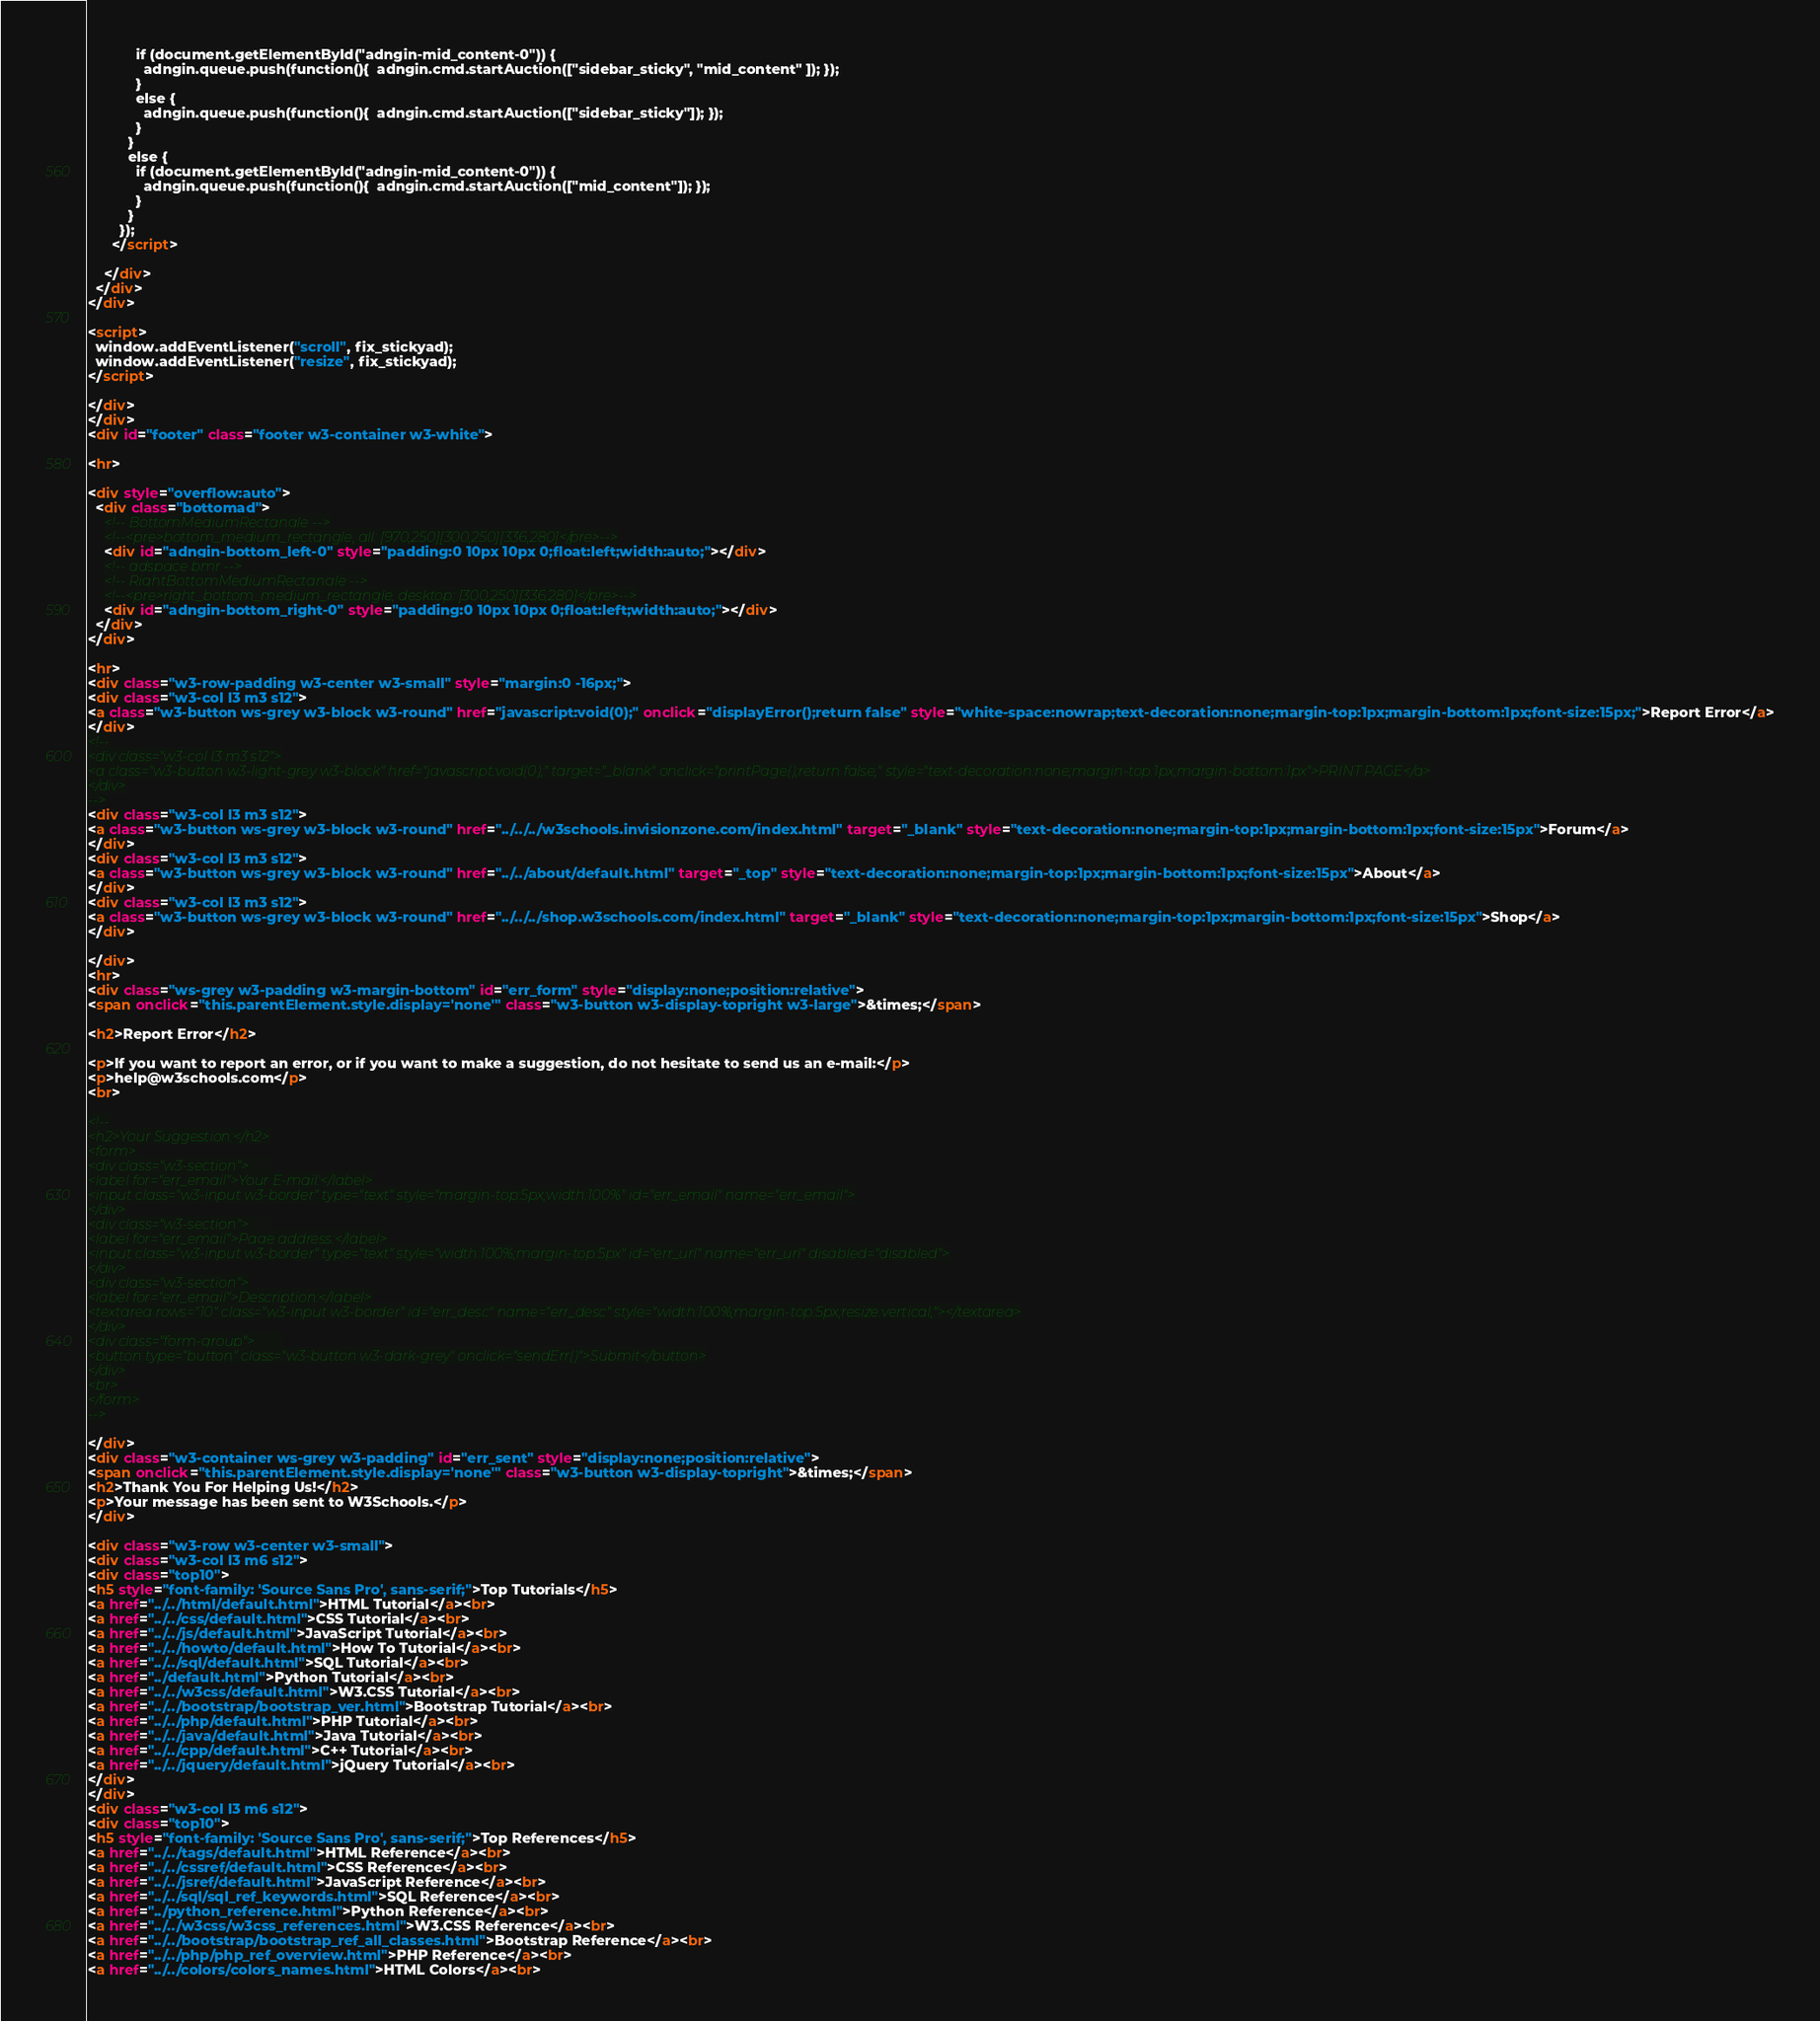<code> <loc_0><loc_0><loc_500><loc_500><_HTML_>            if (document.getElementById("adngin-mid_content-0")) {
              adngin.queue.push(function(){  adngin.cmd.startAuction(["sidebar_sticky", "mid_content" ]); });
            }
            else {
              adngin.queue.push(function(){  adngin.cmd.startAuction(["sidebar_sticky"]); });
            }
          }
          else {
            if (document.getElementById("adngin-mid_content-0")) {
              adngin.queue.push(function(){  adngin.cmd.startAuction(["mid_content"]); });
            }
          }  
        });
      </script>    
      
    </div>
  </div>
</div>

<script>
  window.addEventListener("scroll", fix_stickyad);
  window.addEventListener("resize", fix_stickyad);
</script>

</div>
</div>
<div id="footer" class="footer w3-container w3-white">

<hr>

<div style="overflow:auto">
  <div class="bottomad">
    <!-- BottomMediumRectangle -->
    <!--<pre>bottom_medium_rectangle, all: [970,250][300,250][336,280]</pre>-->
    <div id="adngin-bottom_left-0" style="padding:0 10px 10px 0;float:left;width:auto;"></div>
    <!-- adspace bmr -->
    <!-- RightBottomMediumRectangle -->
    <!--<pre>right_bottom_medium_rectangle, desktop: [300,250][336,280]</pre>-->
    <div id="adngin-bottom_right-0" style="padding:0 10px 10px 0;float:left;width:auto;"></div>
  </div>
</div>

<hr>
<div class="w3-row-padding w3-center w3-small" style="margin:0 -16px;">
<div class="w3-col l3 m3 s12">
<a class="w3-button ws-grey w3-block w3-round" href="javascript:void(0);" onclick="displayError();return false" style="white-space:nowrap;text-decoration:none;margin-top:1px;margin-bottom:1px;font-size:15px;">Report Error</a>
</div>
<!--
<div class="w3-col l3 m3 s12">
<a class="w3-button w3-light-grey w3-block" href="javascript:void(0);" target="_blank" onclick="printPage();return false;" style="text-decoration:none;margin-top:1px;margin-bottom:1px">PRINT PAGE</a>
</div>
-->
<div class="w3-col l3 m3 s12">
<a class="w3-button ws-grey w3-block w3-round" href="../../../w3schools.invisionzone.com/index.html" target="_blank" style="text-decoration:none;margin-top:1px;margin-bottom:1px;font-size:15px">Forum</a>
</div>
<div class="w3-col l3 m3 s12">
<a class="w3-button ws-grey w3-block w3-round" href="../../about/default.html" target="_top" style="text-decoration:none;margin-top:1px;margin-bottom:1px;font-size:15px">About</a>
</div>
<div class="w3-col l3 m3 s12">
<a class="w3-button ws-grey w3-block w3-round" href="../../../shop.w3schools.com/index.html" target="_blank" style="text-decoration:none;margin-top:1px;margin-bottom:1px;font-size:15px">Shop</a>
</div>

</div>
<hr>
<div class="ws-grey w3-padding w3-margin-bottom" id="err_form" style="display:none;position:relative">
<span onclick="this.parentElement.style.display='none'" class="w3-button w3-display-topright w3-large">&times;</span>

<h2>Report Error</h2>

<p>If you want to report an error, or if you want to make a suggestion, do not hesitate to send us an e-mail:</p>
<p>help@w3schools.com</p>
<br>

<!--
<h2>Your Suggestion:</h2>
<form>
<div class="w3-section">      
<label for="err_email">Your E-mail:</label>
<input class="w3-input w3-border" type="text" style="margin-top:5px;width:100%" id="err_email" name="err_email">
</div>
<div class="w3-section">      
<label for="err_email">Page address:</label>
<input class="w3-input w3-border" type="text" style="width:100%;margin-top:5px" id="err_url" name="err_url" disabled="disabled">
</div>
<div class="w3-section">
<label for="err_email">Description:</label>
<textarea rows="10" class="w3-input w3-border" id="err_desc" name="err_desc" style="width:100%;margin-top:5px;resize:vertical;"></textarea>
</div>
<div class="form-group">        
<button type="button" class="w3-button w3-dark-grey" onclick="sendErr()">Submit</button>
</div>
<br>
</form>
-->

</div>
<div class="w3-container ws-grey w3-padding" id="err_sent" style="display:none;position:relative">
<span onclick="this.parentElement.style.display='none'" class="w3-button w3-display-topright">&times;</span>     
<h2>Thank You For Helping Us!</h2>
<p>Your message has been sent to W3Schools.</p>
</div>

<div class="w3-row w3-center w3-small">
<div class="w3-col l3 m6 s12">
<div class="top10">
<h5 style="font-family: 'Source Sans Pro', sans-serif;">Top Tutorials</h5>
<a href="../../html/default.html">HTML Tutorial</a><br>
<a href="../../css/default.html">CSS Tutorial</a><br>
<a href="../../js/default.html">JavaScript Tutorial</a><br>
<a href="../../howto/default.html">How To Tutorial</a><br>
<a href="../../sql/default.html">SQL Tutorial</a><br>
<a href="../default.html">Python Tutorial</a><br>
<a href="../../w3css/default.html">W3.CSS Tutorial</a><br>
<a href="../../bootstrap/bootstrap_ver.html">Bootstrap Tutorial</a><br>
<a href="../../php/default.html">PHP Tutorial</a><br>
<a href="../../java/default.html">Java Tutorial</a><br>
<a href="../../cpp/default.html">C++ Tutorial</a><br>
<a href="../../jquery/default.html">jQuery Tutorial</a><br>
</div>
</div>
<div class="w3-col l3 m6 s12">
<div class="top10">
<h5 style="font-family: 'Source Sans Pro', sans-serif;">Top References</h5>
<a href="../../tags/default.html">HTML Reference</a><br>
<a href="../../cssref/default.html">CSS Reference</a><br>
<a href="../../jsref/default.html">JavaScript Reference</a><br>
<a href="../../sql/sql_ref_keywords.html">SQL Reference</a><br>
<a href="../python_reference.html">Python Reference</a><br>
<a href="../../w3css/w3css_references.html">W3.CSS Reference</a><br>
<a href="../../bootstrap/bootstrap_ref_all_classes.html">Bootstrap Reference</a><br>
<a href="../../php/php_ref_overview.html">PHP Reference</a><br>
<a href="../../colors/colors_names.html">HTML Colors</a><br></code> 